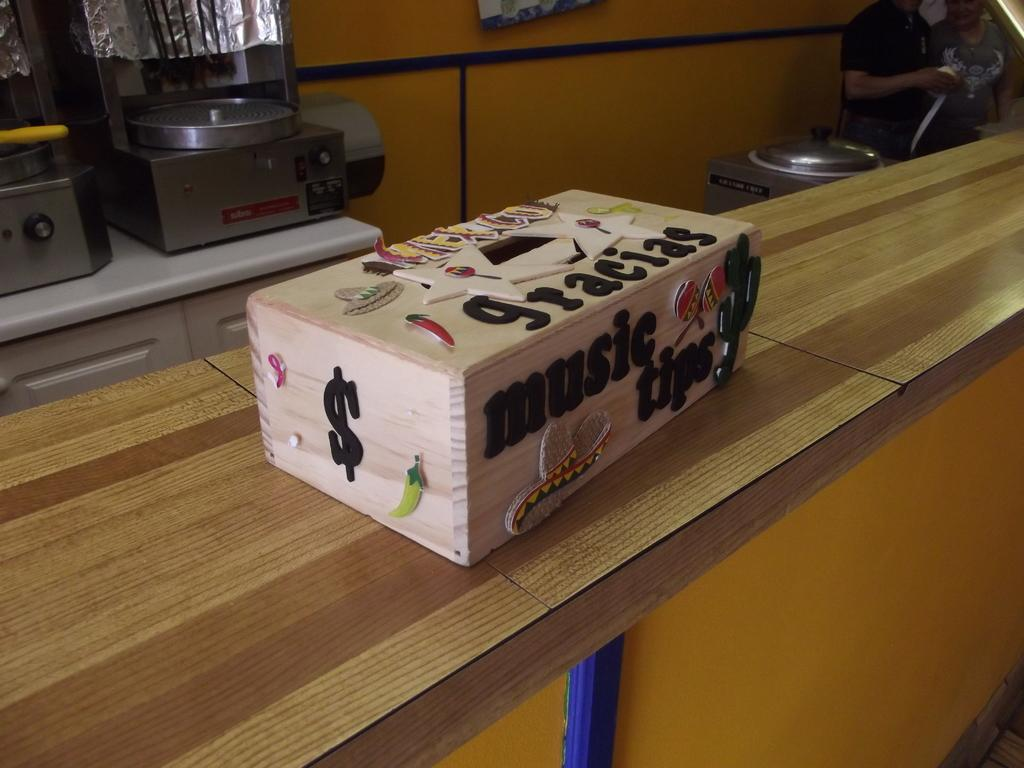Provide a one-sentence caption for the provided image. A wooden box has words music tips on the side of it. 